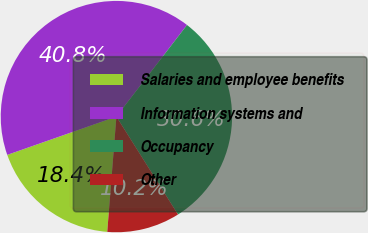Convert chart to OTSL. <chart><loc_0><loc_0><loc_500><loc_500><pie_chart><fcel>Salaries and employee benefits<fcel>Information systems and<fcel>Occupancy<fcel>Other<nl><fcel>18.37%<fcel>40.82%<fcel>30.61%<fcel>10.2%<nl></chart> 